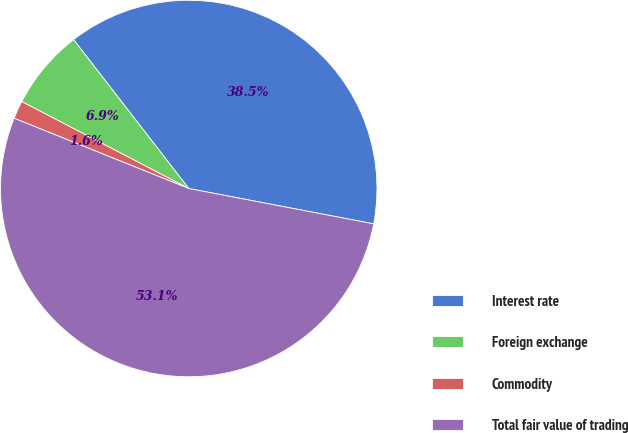<chart> <loc_0><loc_0><loc_500><loc_500><pie_chart><fcel>Interest rate<fcel>Foreign exchange<fcel>Commodity<fcel>Total fair value of trading<nl><fcel>38.48%<fcel>6.88%<fcel>1.55%<fcel>53.08%<nl></chart> 